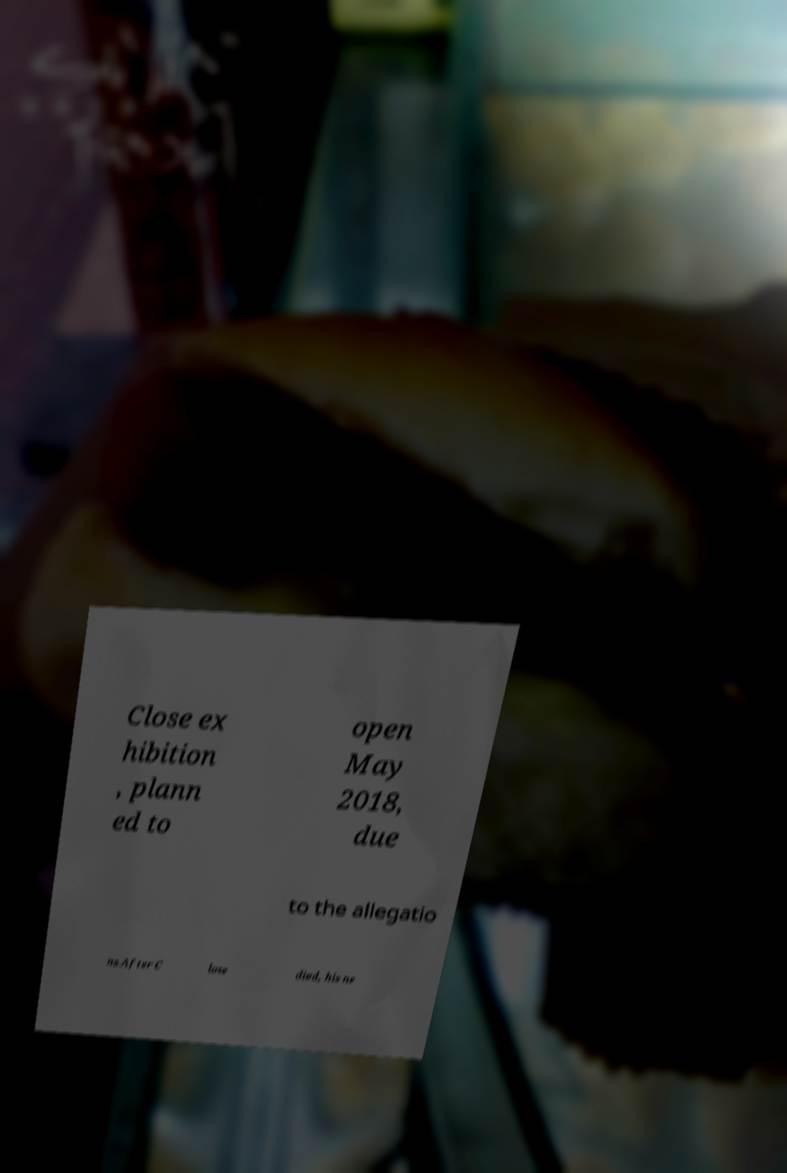Could you assist in decoding the text presented in this image and type it out clearly? Close ex hibition , plann ed to open May 2018, due to the allegatio ns.After C lose died, his ne 